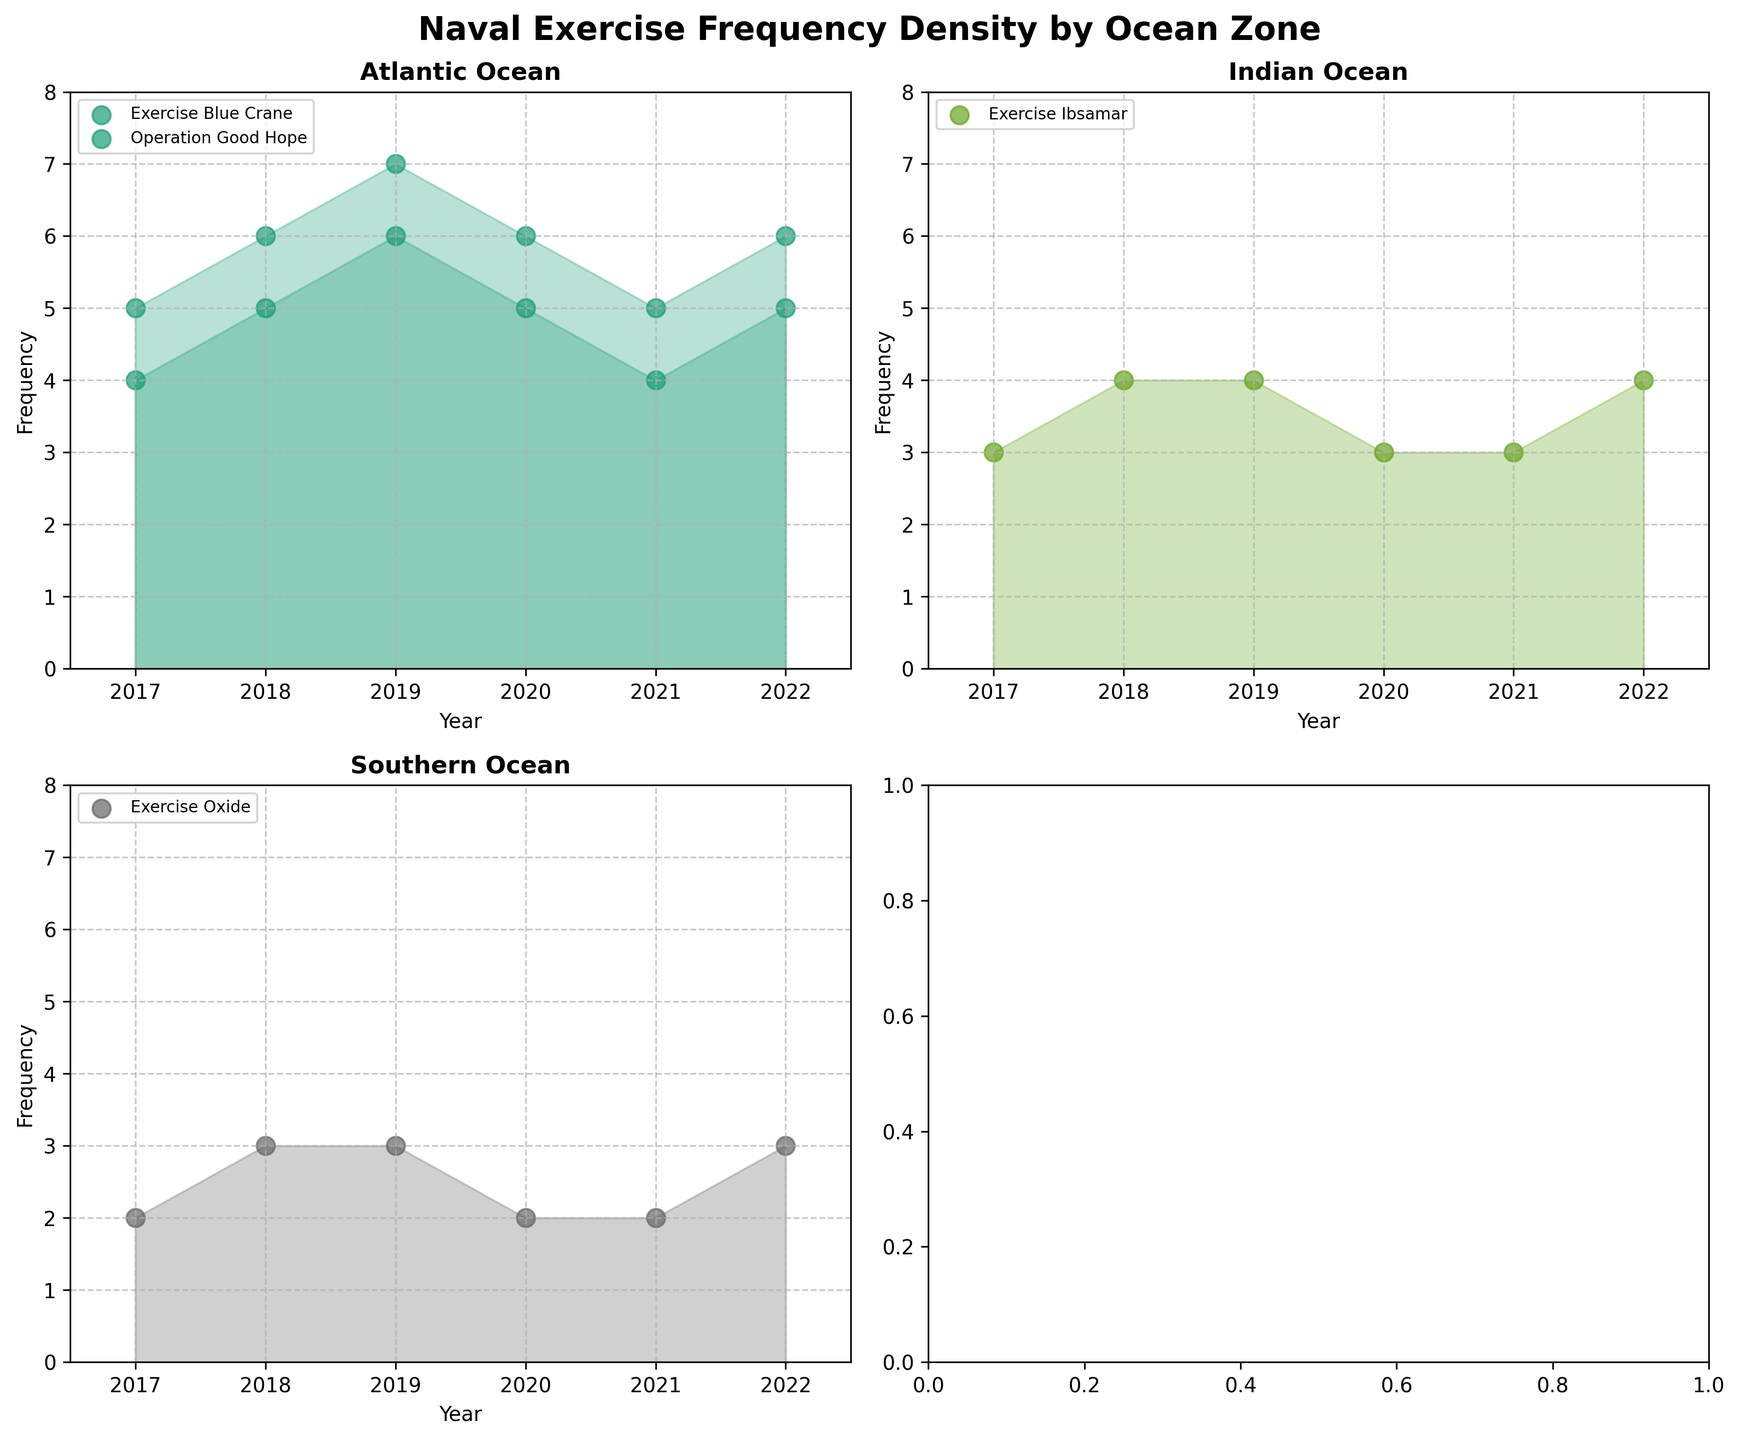How many distinct exercises are conducted in the Atlantic Ocean between 2017 and 2022? Looking at the scatter plots in the Atlantic Ocean subplot, we can count the different exercise names indicated in the legend. The two distinct exercises are Exercise Blue Crane and Operation Good Hope.
Answer: 2 During which year did Exercise Blue Crane in the Atlantic Ocean have its highest frequency? In the Atlantic Ocean subplot, look at the scatter points and shaded areas corresponding to Exercise Blue Crane (likely labeled). Notice the highest point on the vertical axis for this exercise. In 2019, Exercise Blue Crane reached a frequency of 7.
Answer: 2019 Which ocean zone shows a consistent frequency of 3 for Exercise Ibsamar from 2017 to 2021? In the Indian Ocean subplot, identify points plotted for Exercise Ibsamar. They are consistently at a frequency of 3 each year from 2017 through 2021.
Answer: Indian Ocean What is the frequency increase for Exercise Oxide in the Southern Ocean from 2017 to 2022? In the Southern Ocean subplot, observe the frequency of Exercise Oxide in 2017 and 2022. It grows from 2 to 3, giving an increase of 1.
Answer: 1 Compare the frequency trends of Exercise Blue Crane in 2017 and 2021. How do they change in the Atlantic Ocean? In the Atlantic Ocean subplot, locate the frequencies of Exercise Blue Crane for 2017 and 2021. The frequency is 5 in both years, indicating no change.
Answer: No change What is the total frequency of naval exercises conducted in the Atlantic Ocean in 2018? Add the frequencies of Exercise Blue Crane (6) and Operation Good Hope (5) in the Atlantic Ocean subplot for the year 2018. The total is 6 + 5 = 11.
Answer: 11 Which ocean zone has the least variation in exercise frequency between 2017 and 2022? By reviewing the density fills and scatter plots for each zone, the Southern Ocean subplot shows the least variation, with frequencies ranging only from 2 to 3.
Answer: Southern Ocean During which year was the highest frequency of Exercise Ibsamar observed in the Indian Ocean, and what was the frequency? In the Indian Ocean subplot, identify the highest frequency points for Exercise Ibsamar. In 2018 and 2022, the frequency was the highest at 4.
Answer: 2018 and 2022; 4 